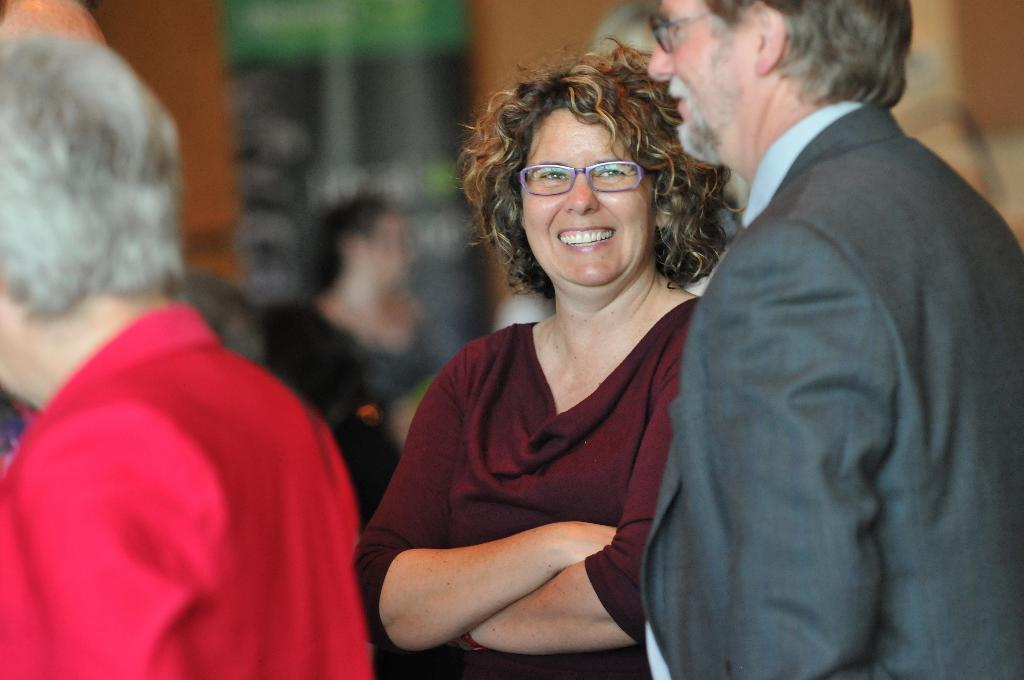Who or what can be seen in the image? There are people in the image. What are the people doing in the image? The people are standing. What is the facial expression of the people in the image? The people are smiling. What type of coast can be seen in the background of the image? There is no coast visible in the image; it only features people standing and smiling. 